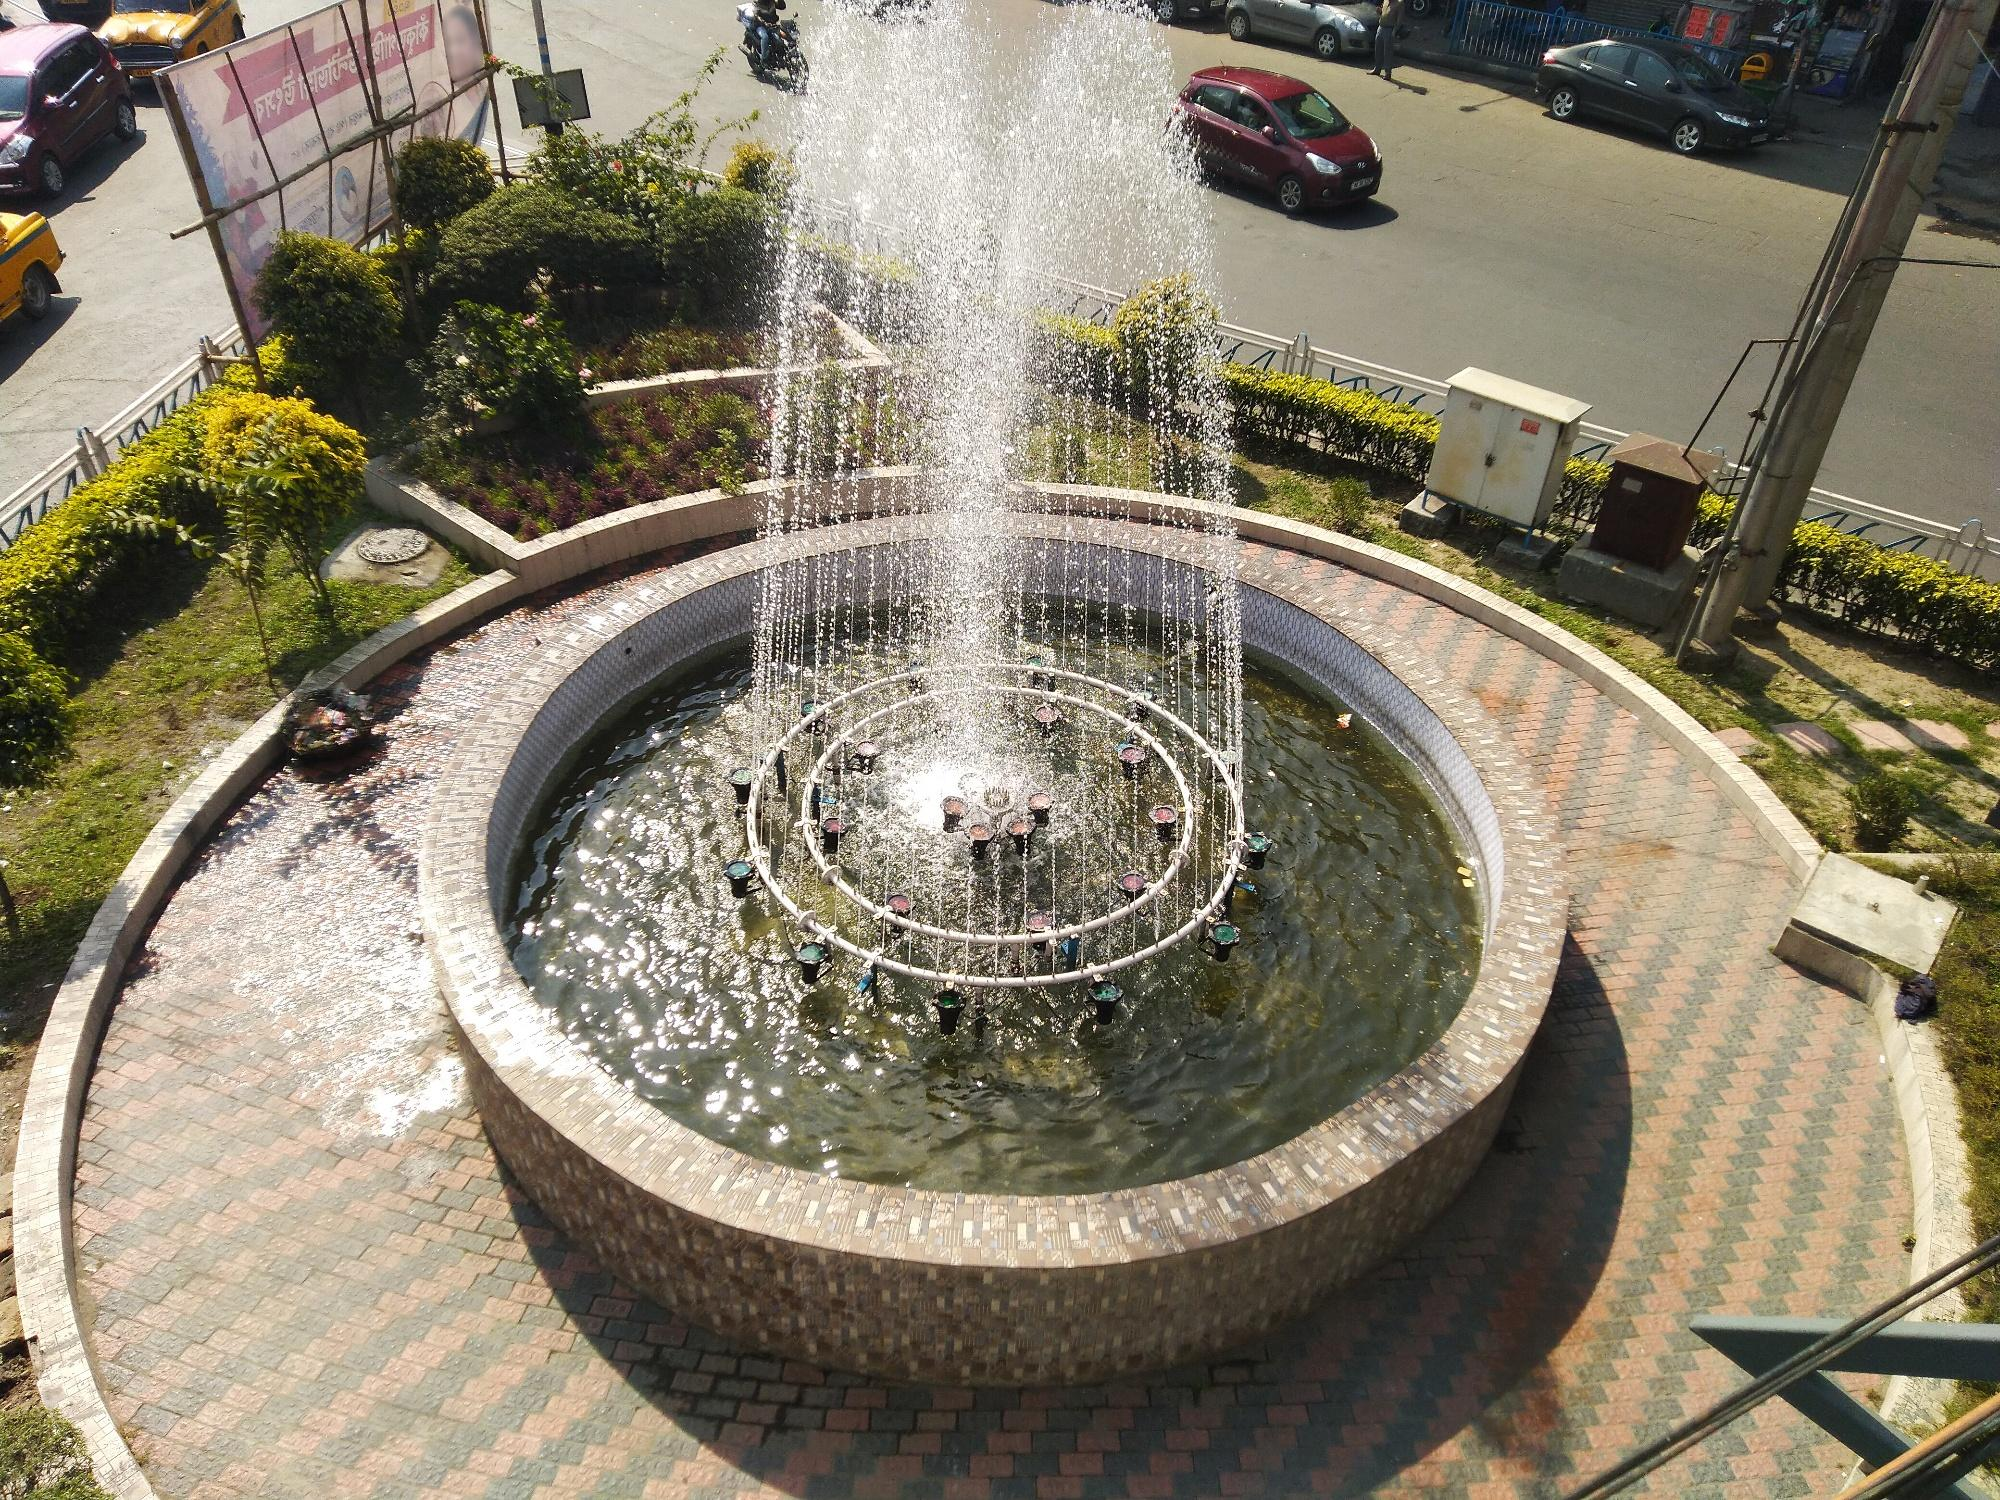Describe how the fountain's appearance might change with the seasons. In spring, the fountain is surrounded by fresh blooms, with vibrant flowers adding splashes of color to the scene. The water dances more brightly under the increasing sunlight.

Summer sees the area become a popular spot for respite from the heat, with lush greenery providing shade and the water spray offering cool relief. The bright light of long days makes the fountain sparkle.

As autumn arrives, the foliage surrounding the fountain turns into a rich tapestry of reds, oranges, and yellows. Fallen leaves may dot the surface of the water, adding to the tranquil beauty.

During winter, if the climate permits, the fountain might be turned off to prevent freezing damage, and a blanket of snow could cover the surroundings. This would create a peaceful, monochromatic scene, with the brick base providing a stark contrast to the white snow. 